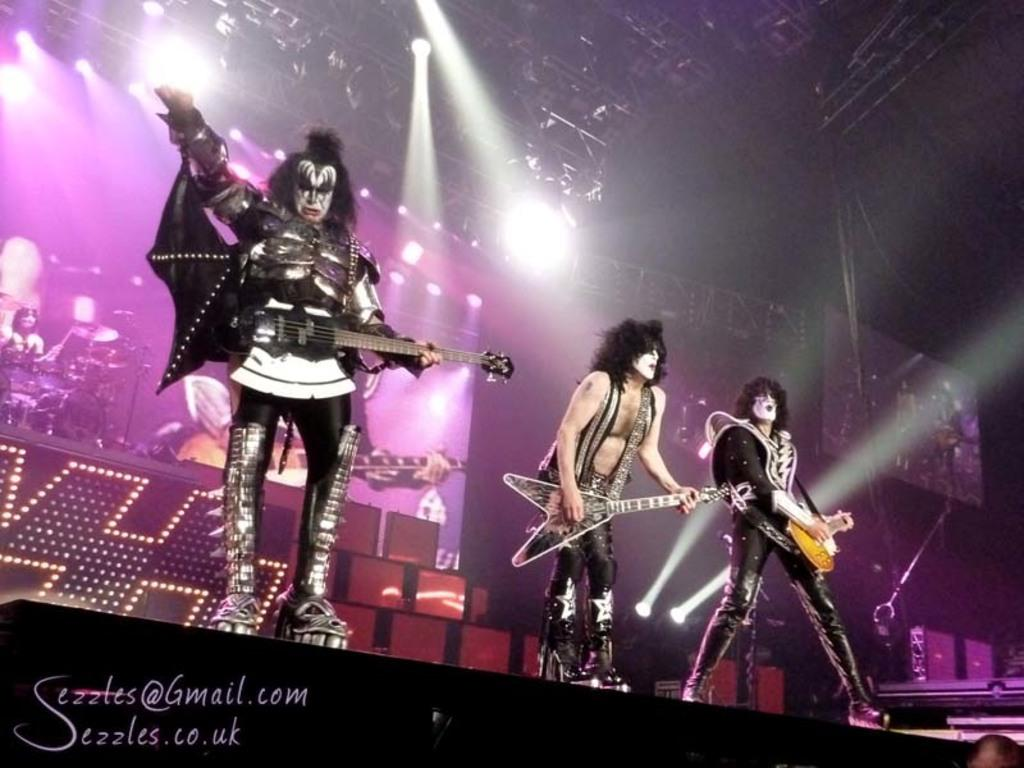How many people are in the image? There are three persons in the image. What are the persons doing in the image? The persons are standing and playing a guitar. What can be seen in the distance in the image? There are focusing lights in the distance. What is the banner in the image depicting? The banner has musical instruments depicted on it. What is the father of the beginner guitarist doing in the image? There is no mention of a beginner guitarist or a father in the image, so this question cannot be answered definitively. 